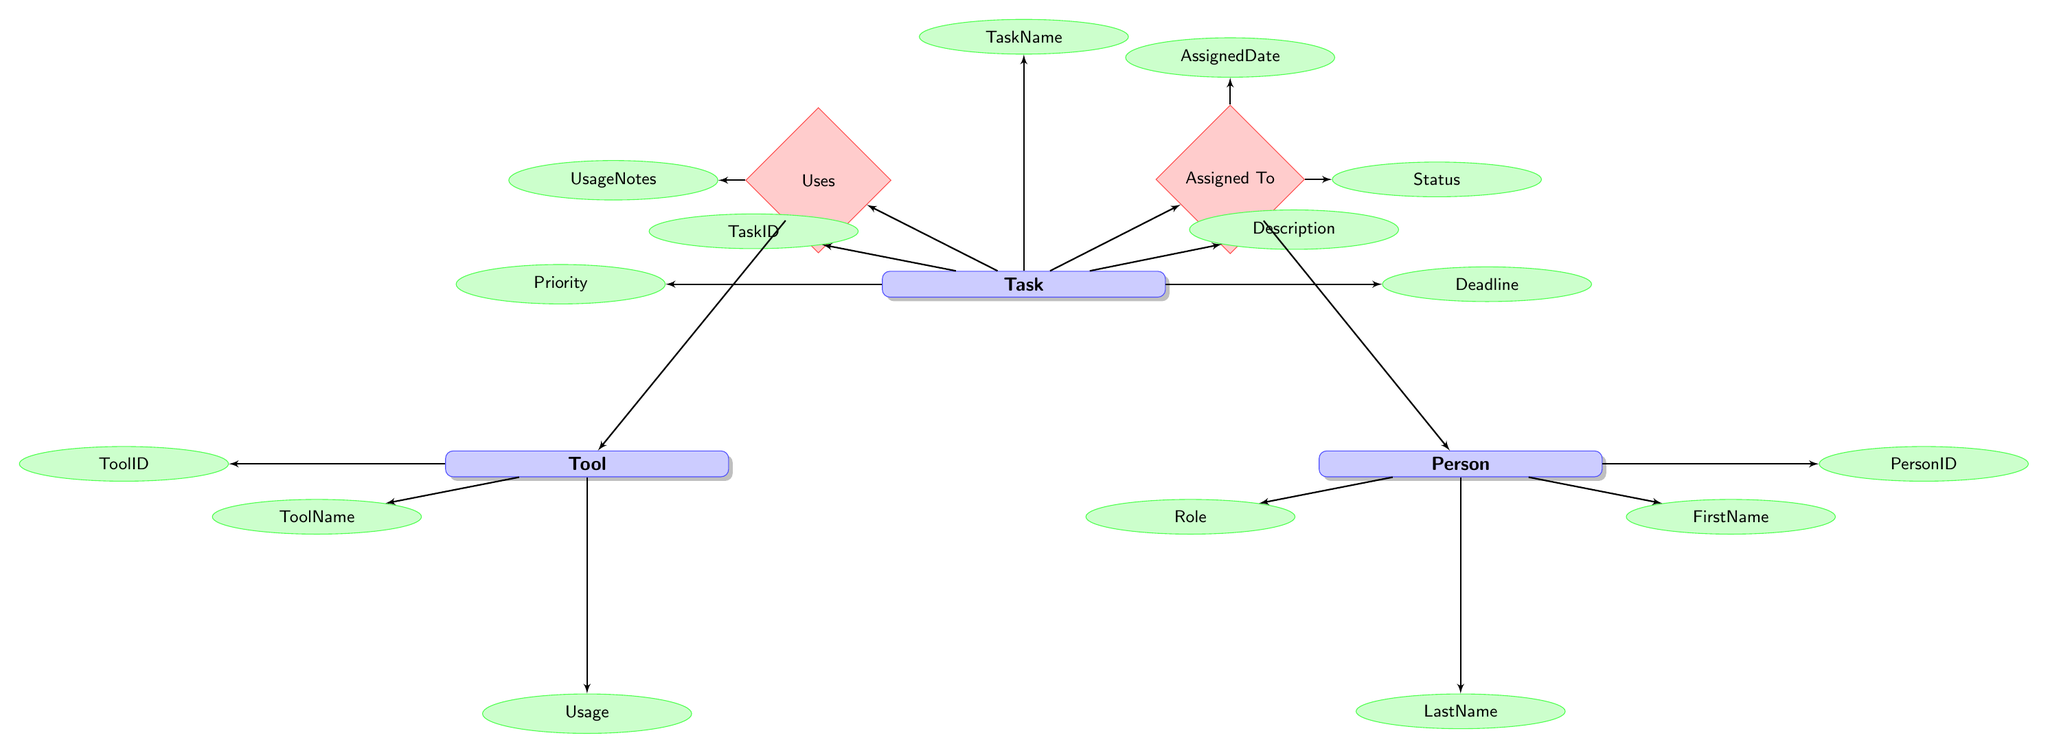What is the primary key for the Task entity? The primary key for the Task entity is "TaskID", which identifies each task uniquely within the entity.
Answer: TaskID How many entities are represented in the diagram? The diagram includes three entities: Task, Person, and Tool, which can be counted by identifying the entity nodes.
Answer: 3 What relationship connects the Task and Person entities? The relationship connecting the Task and Person entities is called "Assigned To", indicating task assignments to individuals.
Answer: Assigned To Which attribute indicates the priority of a task? The attribute indicating the priority of a task is "Priority", which describes its urgency level as High, Medium, or Low.
Answer: Priority How many attributes does the Tool entity have? The Tool entity has three attributes: ToolID, ToolName, and Usage, which can be determined by counting the linked attribute nodes.
Answer: 3 Which relationship has the attribute "UsageNotes"? The relationship that includes the attribute "UsageNotes" is "Uses", which details how the tool is utilized for the task.
Answer: Uses What status options are available for a task? The status options available for a task are "Not Started", "In Progress", and "Completed", which describe the current state of the task.
Answer: Not Started, In Progress, Completed What is the primary key for the Person entity? The primary key for the Person entity is "PersonID", allowing for the unique identification of individuals associated with tasks.
Answer: PersonID Which entity would use a tool? The entity that would use a tool is "Task", as it specifies the tasks that utilize specific tools for their completion.
Answer: Task 